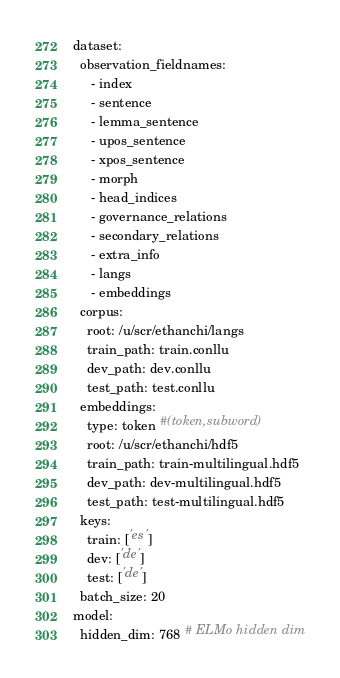<code> <loc_0><loc_0><loc_500><loc_500><_YAML_>dataset:
  observation_fieldnames:
     - index
     - sentence
     - lemma_sentence
     - upos_sentence
     - xpos_sentence
     - morph
     - head_indices
     - governance_relations
     - secondary_relations
     - extra_info
     - langs
     - embeddings
  corpus:
    root: /u/scr/ethanchi/langs
    train_path: train.conllu
    dev_path: dev.conllu
    test_path: test.conllu 
  embeddings:
    type: token #(token,subword)
    root: /u/scr/ethanchi/hdf5
    train_path: train-multilingual.hdf5
    dev_path: dev-multilingual.hdf5
    test_path: test-multilingual.hdf5
  keys:
    train: ['es']
    dev: ['de']
    test: ['de']
  batch_size: 20
model:
  hidden_dim: 768 # ELMo hidden dim</code> 